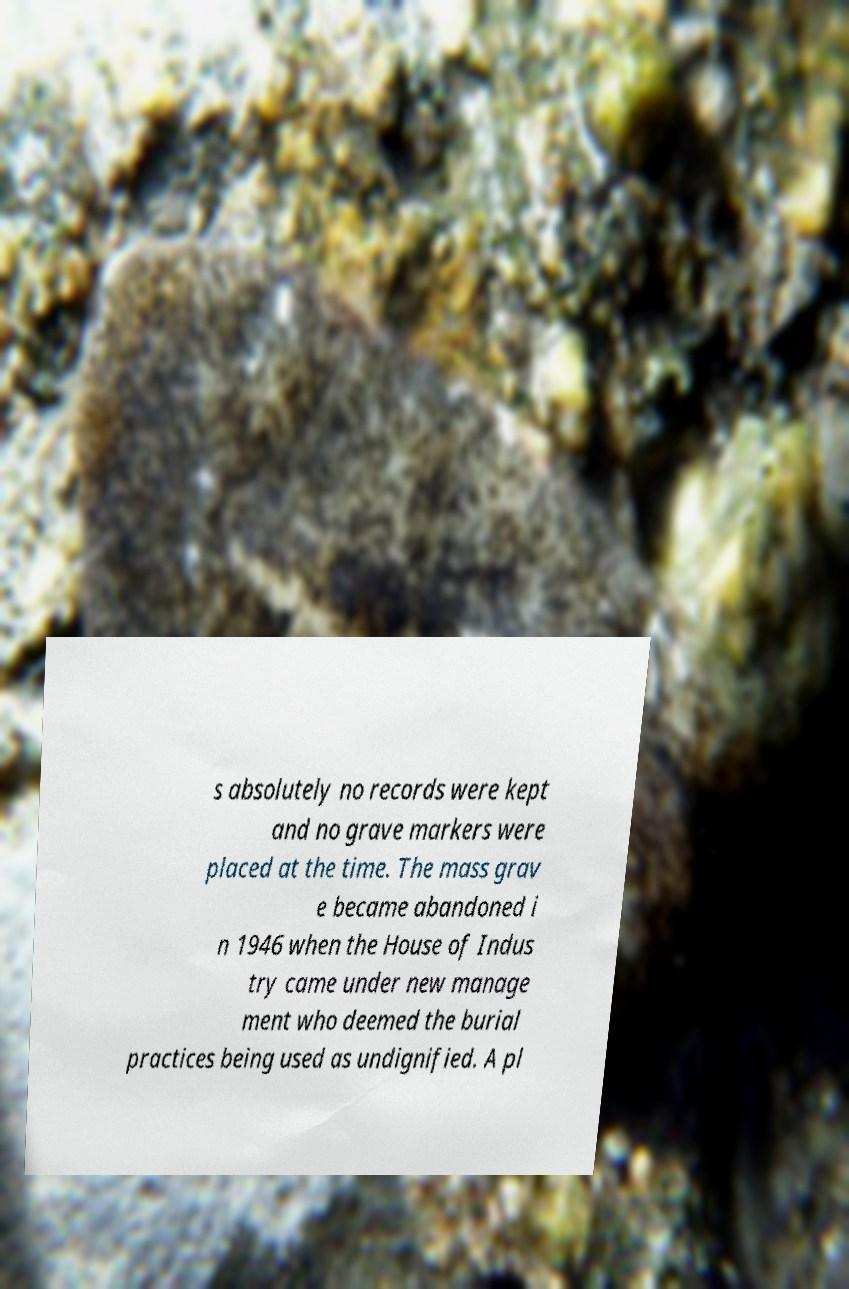Please identify and transcribe the text found in this image. s absolutely no records were kept and no grave markers were placed at the time. The mass grav e became abandoned i n 1946 when the House of Indus try came under new manage ment who deemed the burial practices being used as undignified. A pl 